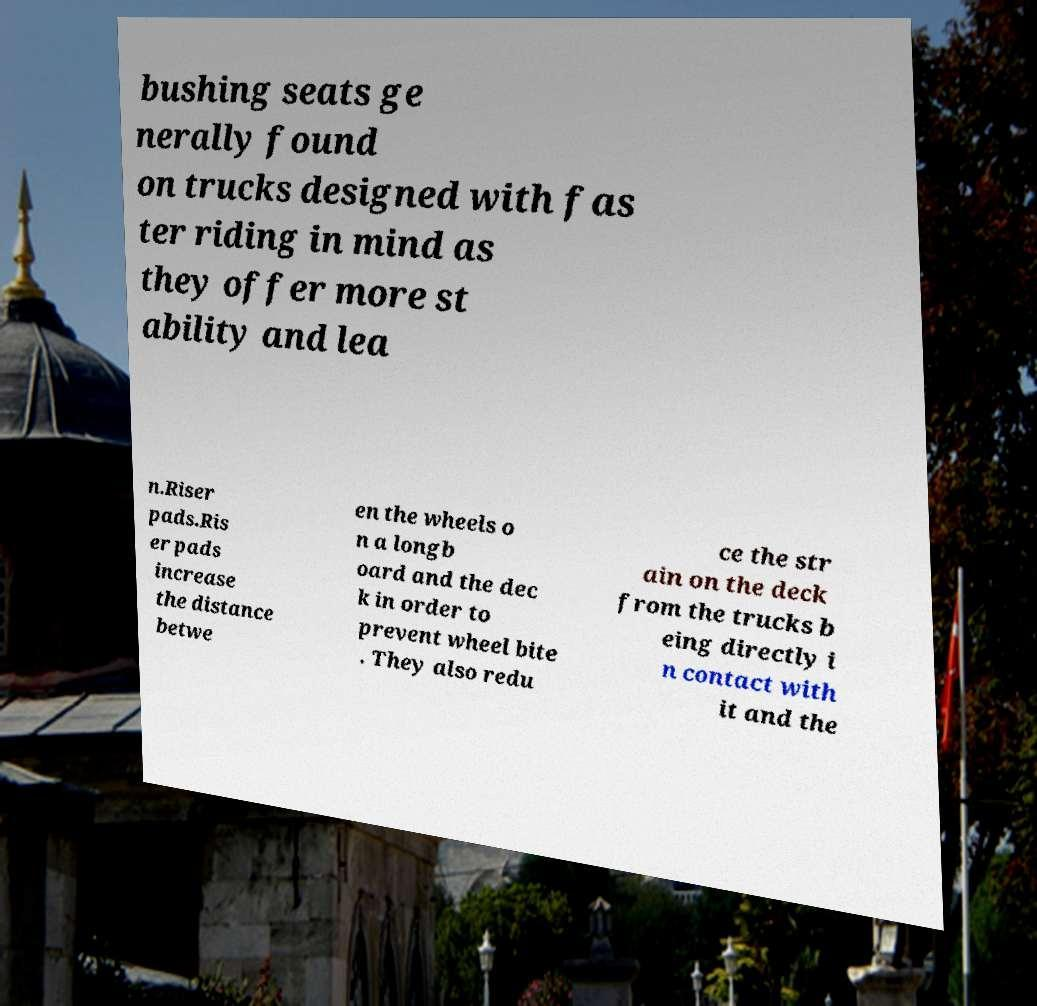Could you extract and type out the text from this image? bushing seats ge nerally found on trucks designed with fas ter riding in mind as they offer more st ability and lea n.Riser pads.Ris er pads increase the distance betwe en the wheels o n a longb oard and the dec k in order to prevent wheel bite . They also redu ce the str ain on the deck from the trucks b eing directly i n contact with it and the 